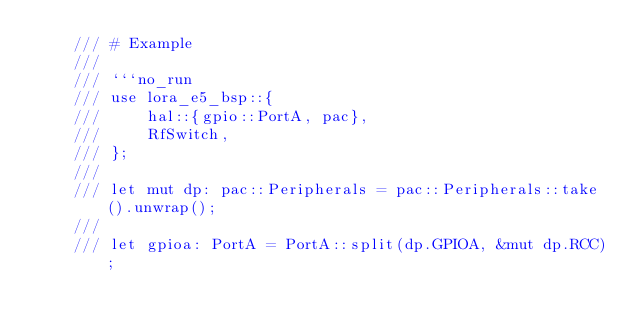<code> <loc_0><loc_0><loc_500><loc_500><_Rust_>    /// # Example
    ///
    /// ```no_run
    /// use lora_e5_bsp::{
    ///     hal::{gpio::PortA, pac},
    ///     RfSwitch,
    /// };
    ///
    /// let mut dp: pac::Peripherals = pac::Peripherals::take().unwrap();
    ///
    /// let gpioa: PortA = PortA::split(dp.GPIOA, &mut dp.RCC);</code> 